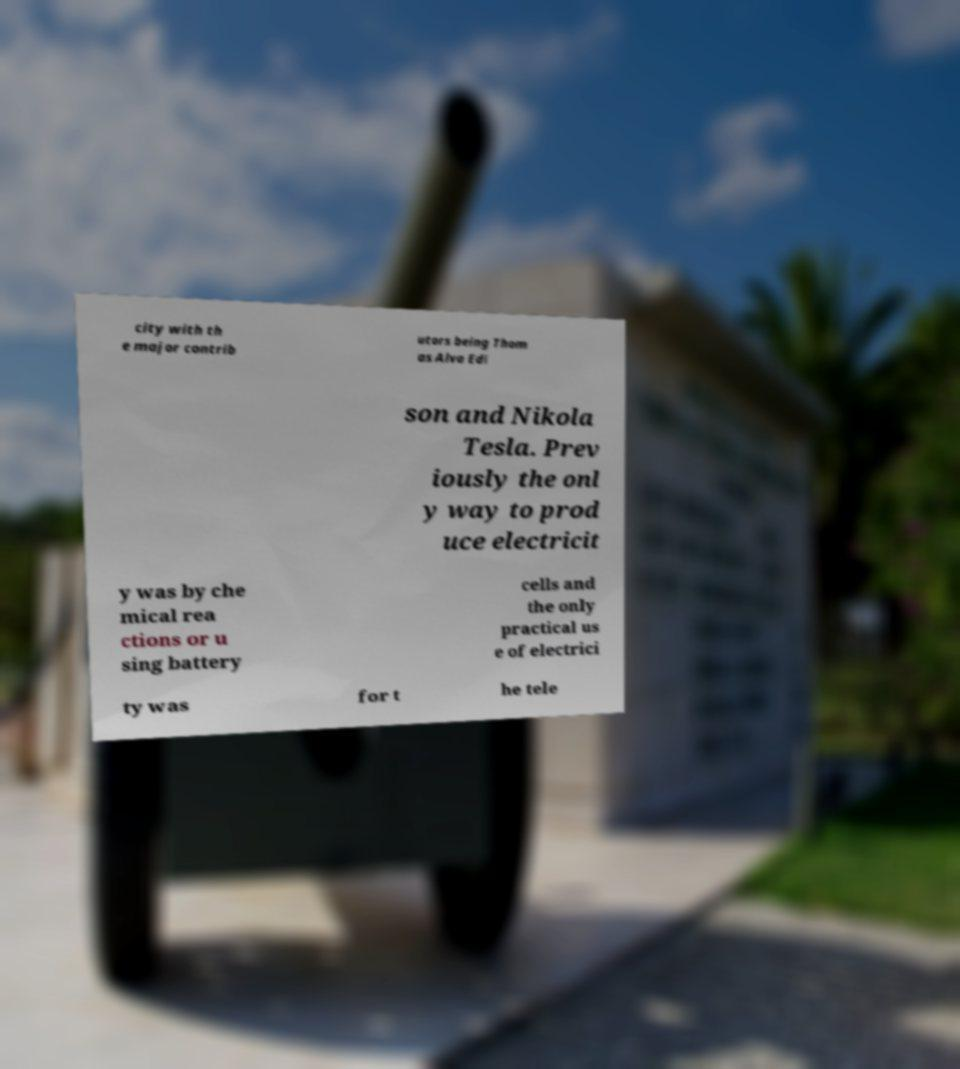What messages or text are displayed in this image? I need them in a readable, typed format. city with th e major contrib utors being Thom as Alva Edi son and Nikola Tesla. Prev iously the onl y way to prod uce electricit y was by che mical rea ctions or u sing battery cells and the only practical us e of electrici ty was for t he tele 